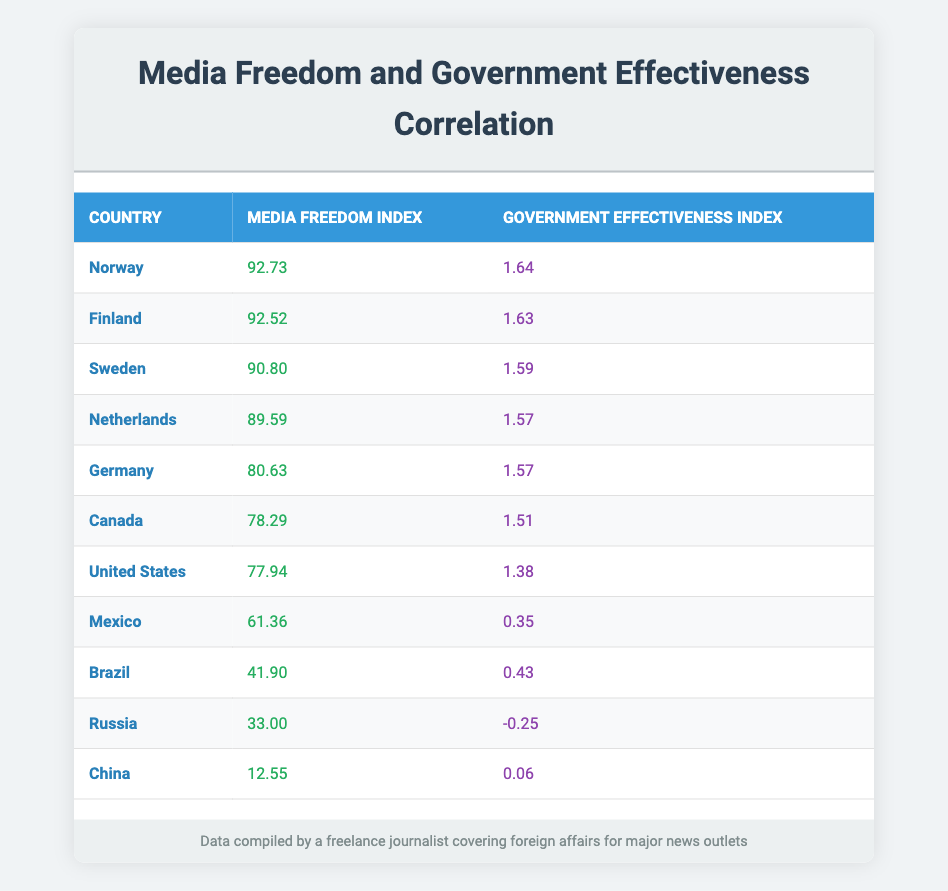What is the media freedom index of Norway? According to the table, Norway has a media freedom index of 92.73.
Answer: 92.73 Which country has the lowest government effectiveness index? Upon reviewing the table, Russia has the lowest government effectiveness index at -0.25.
Answer: Russia What is the difference in media freedom index between Finland and Sweden? Finland has a media freedom index of 92.52 and Sweden has 90.80. The difference is 92.52 - 90.80 = 1.72.
Answer: 1.72 Is the media freedom index of Canada higher than that of Brazil? Canada has a media freedom index of 78.29 while Brazil has 41.90. Since 78.29 is greater than 41.90, the statement is true.
Answer: Yes What is the average media freedom index of the countries listed in the table? To calculate the average, sum all the media freedom indices: 92.73 + 92.52 + 90.80 + 89.59 + 80.63 + 78.29 + 77.94 + 61.36 + 41.90 + 33.00 + 12.55 =  718.27. Then, divide by the number of countries (11): 718.27 / 11 = 65.25.
Answer: 65.25 How many countries have a media freedom index above 80? From the table, Norway, Finland, Sweden, Netherlands, and Germany have media freedom indices above 80. This is a total of 5 countries.
Answer: 5 